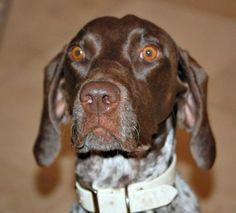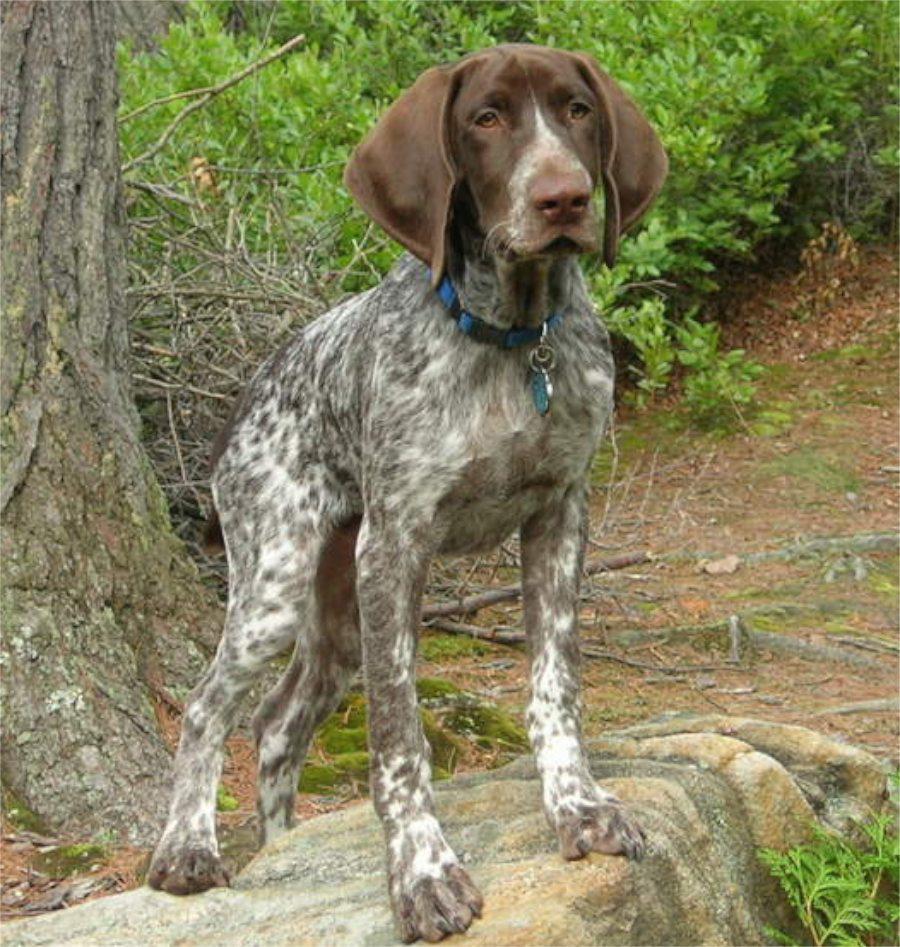The first image is the image on the left, the second image is the image on the right. Examine the images to the left and right. Is the description "Each image shows one dog wearing a collar, and no image shows a dog in an action pose." accurate? Answer yes or no. Yes. The first image is the image on the left, the second image is the image on the right. Analyze the images presented: Is the assertion "The dog in the left image is wearing a collar." valid? Answer yes or no. Yes. 